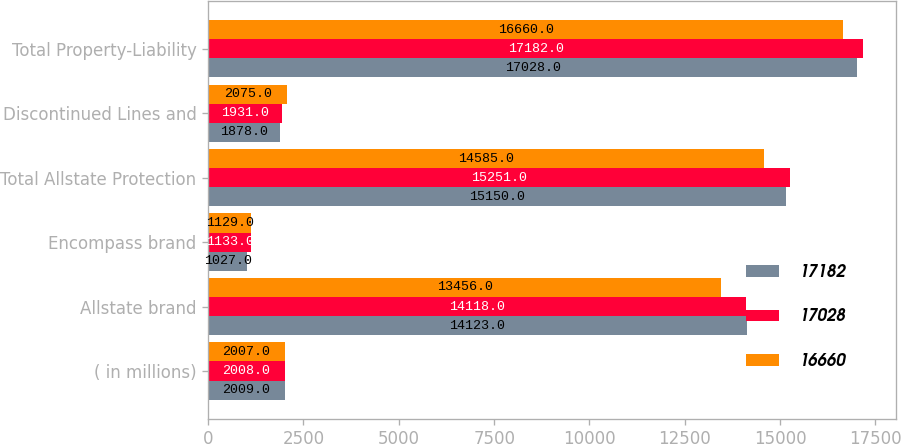<chart> <loc_0><loc_0><loc_500><loc_500><stacked_bar_chart><ecel><fcel>( in millions)<fcel>Allstate brand<fcel>Encompass brand<fcel>Total Allstate Protection<fcel>Discontinued Lines and<fcel>Total Property-Liability<nl><fcel>17182<fcel>2009<fcel>14123<fcel>1027<fcel>15150<fcel>1878<fcel>17028<nl><fcel>17028<fcel>2008<fcel>14118<fcel>1133<fcel>15251<fcel>1931<fcel>17182<nl><fcel>16660<fcel>2007<fcel>13456<fcel>1129<fcel>14585<fcel>2075<fcel>16660<nl></chart> 